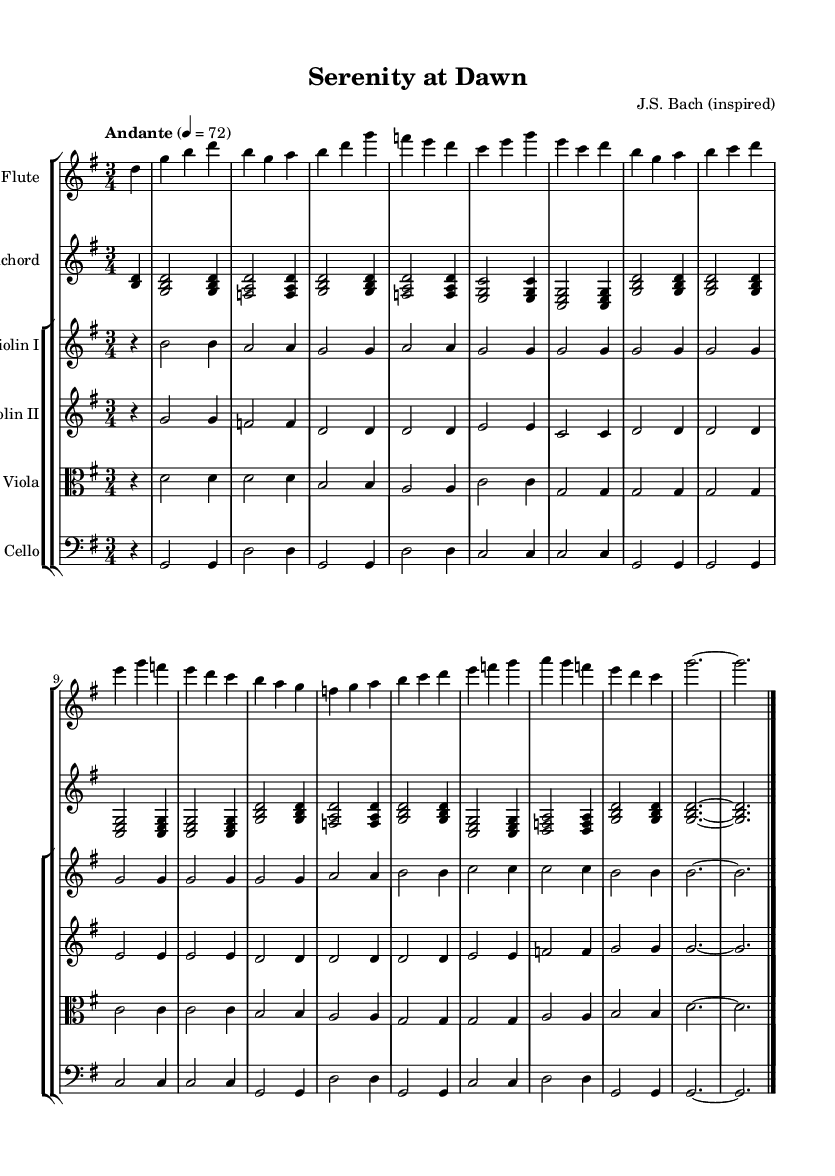what is the key signature of this music? The key signature is G major, which has one sharp (F#). You can identify the key signature by looking at the beginning of the staff where the sharps or flats are indicated.
Answer: G major what is the time signature of this music? The time signature is 3/4, which indicates that there are three beats in each measure and each beat is a quarter note. This is seen at the beginning of the staff, just after the key signature.
Answer: 3/4 what is the tempo marking for this piece? The tempo marking is Andante, which indicates a moderately slow tempo. This can be found written at the beginning of the music, typically near the top.
Answer: Andante how many instruments are featured in this composition? There are six instruments featured in this composition: Flute, Harpsichord, Violin I, Violin II, Viola, and Cello. Each instrument is indicated at the start of its staff.
Answer: Six which instrument plays the melody predominantly? The Flute predominantly plays the melody in this piece. This can be observed as it is the instrument with the most prominent and flowing lines throughout the music.
Answer: Flute what is the structure of the piece based on the instrumentation? The structure is defined as a concerto featuring a solo flute with an accompaniment of strings and harpsichord. This is characteristic of Baroque concertos, where a solo instrument contrasts against an ensemble.
Answer: Concerto which style of music does this piece belong to? This piece belongs to the Baroque style, which is recognized for its ornate melodies and complex counterpoint. This can be deduced from the instrumentation and the composer's inspiration noted at the top of the sheet.
Answer: Baroque 